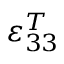Convert formula to latex. <formula><loc_0><loc_0><loc_500><loc_500>\varepsilon _ { 3 3 } ^ { T }</formula> 